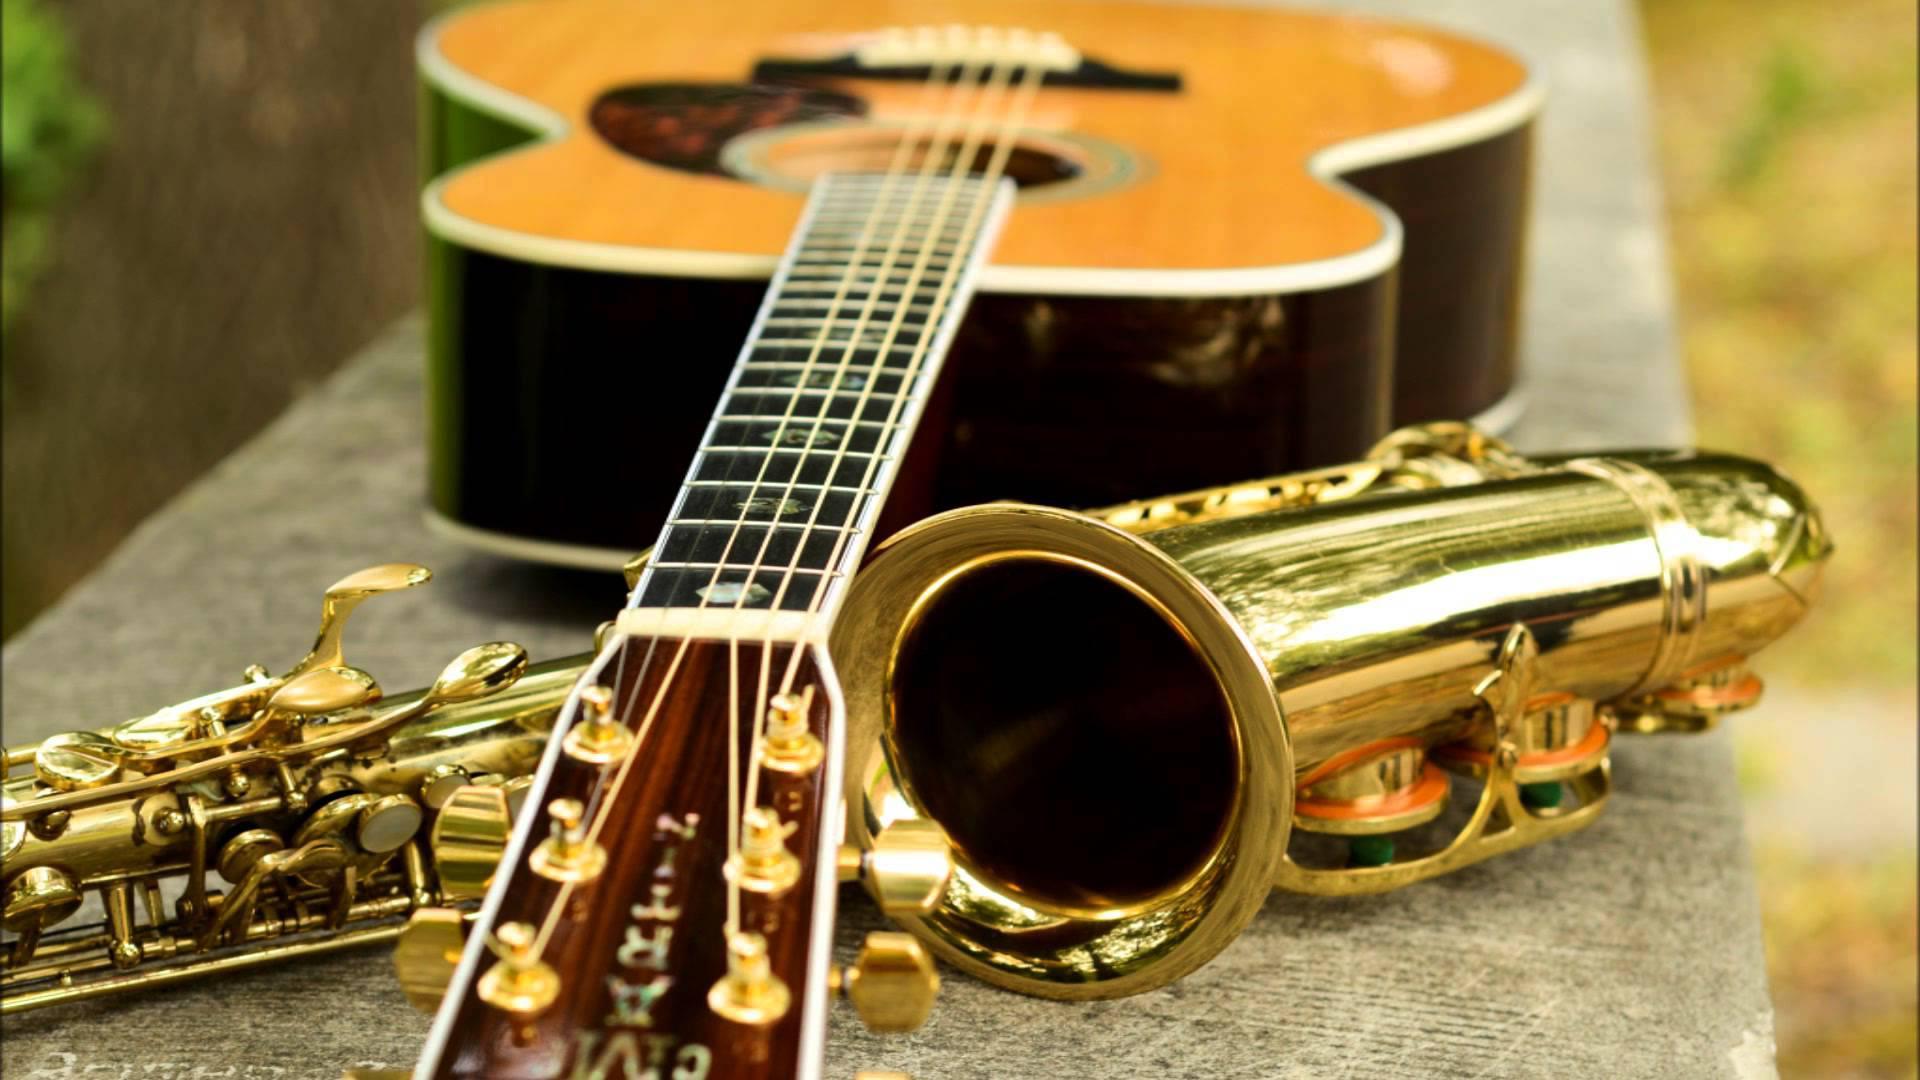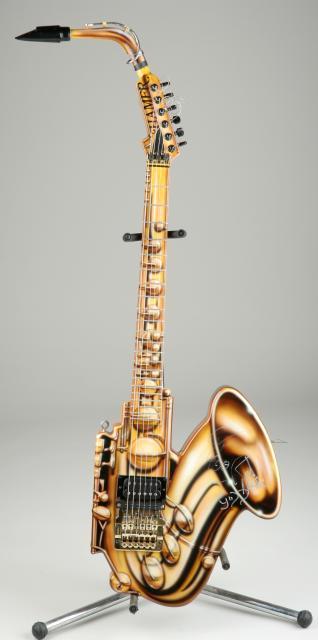The first image is the image on the left, the second image is the image on the right. Analyze the images presented: Is the assertion "There are two saxophones and one guitar" valid? Answer yes or no. Yes. The first image is the image on the left, the second image is the image on the right. Assess this claim about the two images: "The left and right image contains the same number of saxophones and guitars.". Correct or not? Answer yes or no. No. 